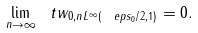Convert formula to latex. <formula><loc_0><loc_0><loc_500><loc_500>\lim _ { n \to \infty } \| \ t w _ { 0 , n } \| _ { L ^ { \infty } ( \ e p s _ { 0 } / 2 , 1 ) } = 0 .</formula> 